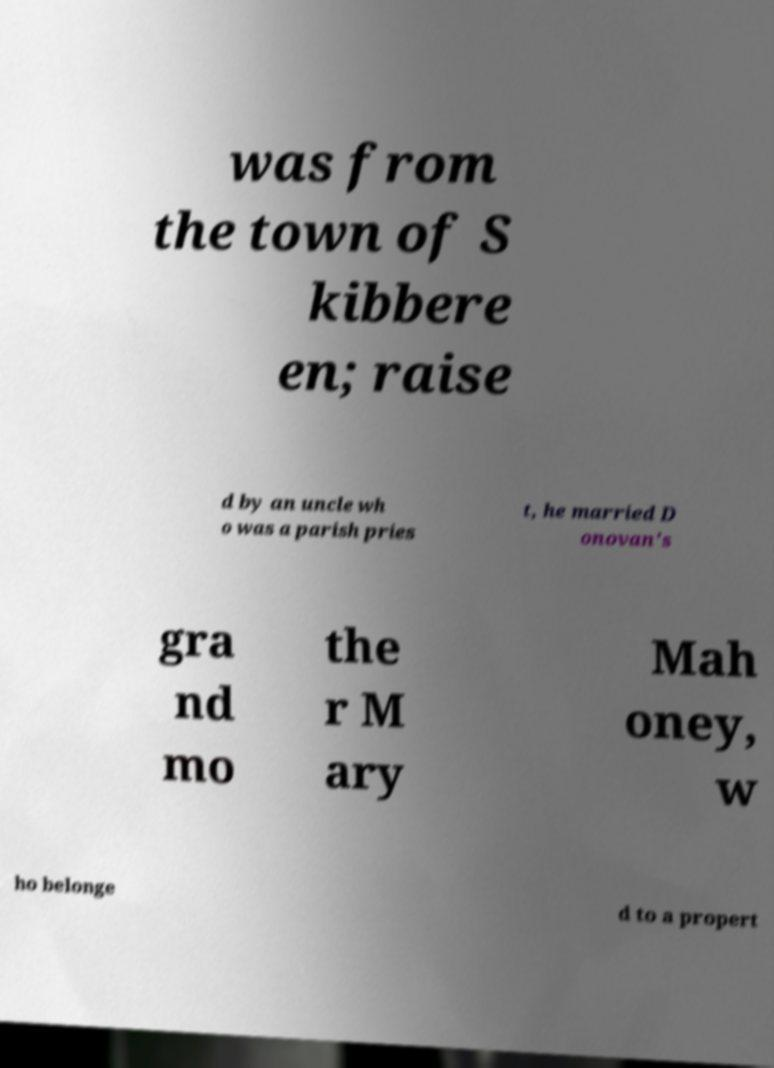Please identify and transcribe the text found in this image. was from the town of S kibbere en; raise d by an uncle wh o was a parish pries t, he married D onovan's gra nd mo the r M ary Mah oney, w ho belonge d to a propert 